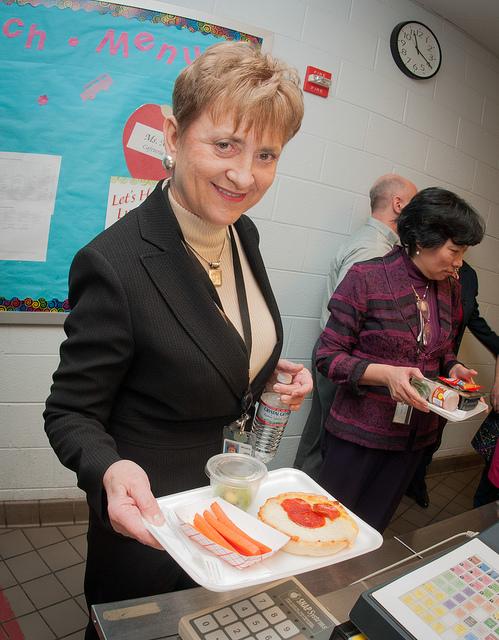What is written behind them?
Keep it brief. Menu. What food is on the table?
Answer briefly. None. What are the people wearing?
Write a very short answer. Suits. What type of food does the man have?
Quick response, please. Carrots. What color is the lanyard?
Short answer required. Black. Is it lunch time?
Keep it brief. Yes. Which hand is holding the glass?
Give a very brief answer. Left. Are the people pictured eating together?
Answer briefly. Yes. What is the girl holding?
Be succinct. Tray. What beverage does the woman have?
Answer briefly. Water. Is anyone in this workplace wearing a coat?
Concise answer only. No. 